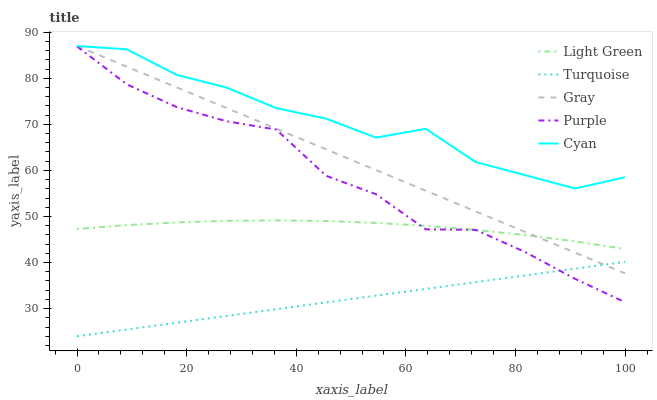Does Turquoise have the minimum area under the curve?
Answer yes or no. Yes. Does Cyan have the maximum area under the curve?
Answer yes or no. Yes. Does Gray have the minimum area under the curve?
Answer yes or no. No. Does Gray have the maximum area under the curve?
Answer yes or no. No. Is Turquoise the smoothest?
Answer yes or no. Yes. Is Cyan the roughest?
Answer yes or no. Yes. Is Gray the smoothest?
Answer yes or no. No. Is Gray the roughest?
Answer yes or no. No. Does Turquoise have the lowest value?
Answer yes or no. Yes. Does Gray have the lowest value?
Answer yes or no. No. Does Cyan have the highest value?
Answer yes or no. Yes. Does Turquoise have the highest value?
Answer yes or no. No. Is Turquoise less than Cyan?
Answer yes or no. Yes. Is Cyan greater than Purple?
Answer yes or no. Yes. Does Turquoise intersect Purple?
Answer yes or no. Yes. Is Turquoise less than Purple?
Answer yes or no. No. Is Turquoise greater than Purple?
Answer yes or no. No. Does Turquoise intersect Cyan?
Answer yes or no. No. 